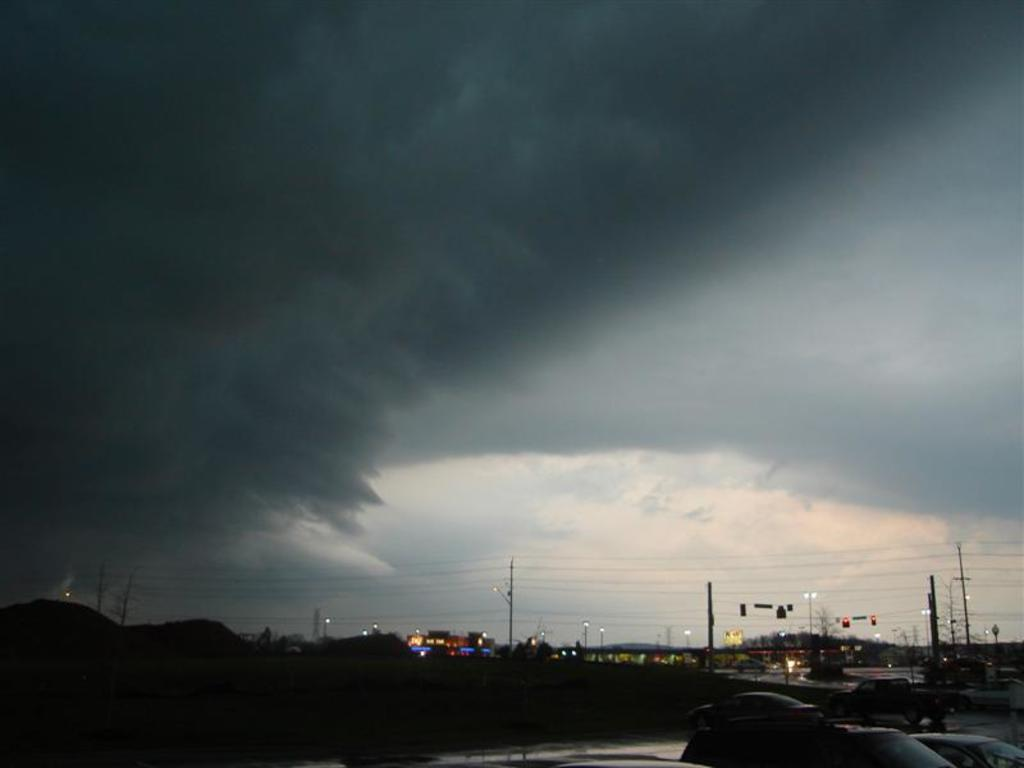What structures can be seen in the image? There are poles, lights, buildings, and trees in the image. What else can be seen in the image besides structures? There are vehicles in the image. What is visible in the background of the image? The sky is visible in the background of the image, and there are clouds in the sky. Where is the patch located in the image? There is no patch present in the image. What type of drink is being served in the bottle in the image? There is no bottle or drink present in the image. 